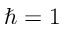<formula> <loc_0><loc_0><loc_500><loc_500>\hbar { = } 1</formula> 